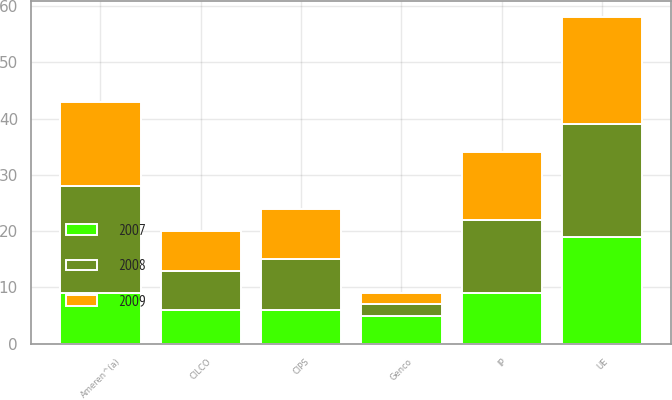<chart> <loc_0><loc_0><loc_500><loc_500><stacked_bar_chart><ecel><fcel>Ameren^(a)<fcel>UE<fcel>CIPS<fcel>Genco<fcel>CILCO<fcel>IP<nl><fcel>2007<fcel>9<fcel>19<fcel>6<fcel>5<fcel>6<fcel>9<nl><fcel>2008<fcel>19<fcel>20<fcel>9<fcel>2<fcel>7<fcel>13<nl><fcel>2009<fcel>15<fcel>19<fcel>9<fcel>2<fcel>7<fcel>12<nl></chart> 